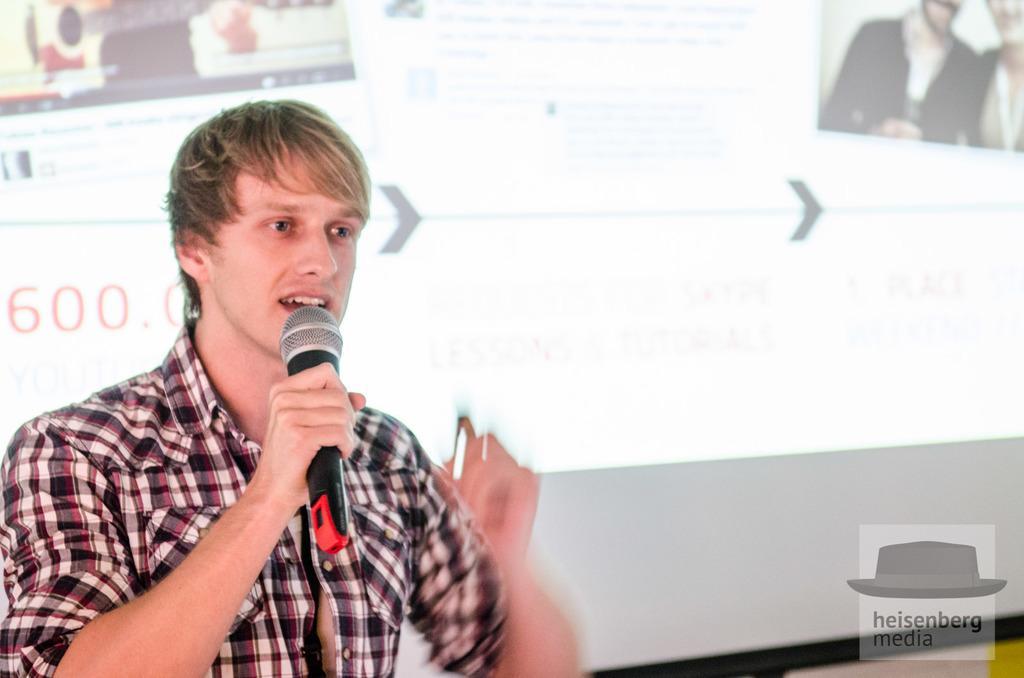Could you give a brief overview of what you see in this image? In this picture we can see a man holding a mic with his hand and talking and in the background we can see a screen. 